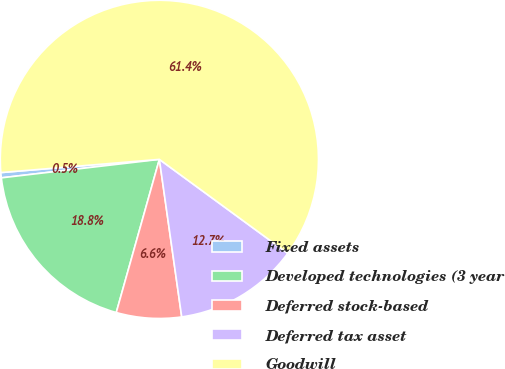<chart> <loc_0><loc_0><loc_500><loc_500><pie_chart><fcel>Fixed assets<fcel>Developed technologies (3 year<fcel>Deferred stock-based<fcel>Deferred tax asset<fcel>Goodwill<nl><fcel>0.53%<fcel>18.78%<fcel>6.61%<fcel>12.7%<fcel>61.38%<nl></chart> 